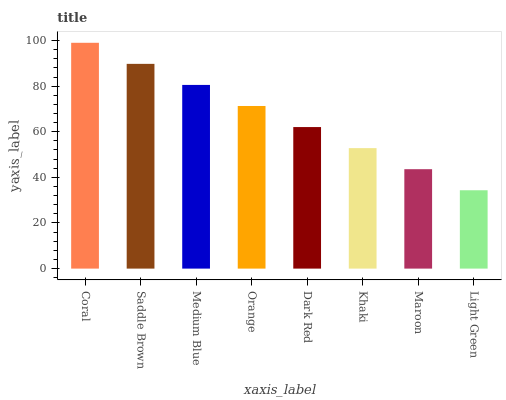Is Light Green the minimum?
Answer yes or no. Yes. Is Coral the maximum?
Answer yes or no. Yes. Is Saddle Brown the minimum?
Answer yes or no. No. Is Saddle Brown the maximum?
Answer yes or no. No. Is Coral greater than Saddle Brown?
Answer yes or no. Yes. Is Saddle Brown less than Coral?
Answer yes or no. Yes. Is Saddle Brown greater than Coral?
Answer yes or no. No. Is Coral less than Saddle Brown?
Answer yes or no. No. Is Orange the high median?
Answer yes or no. Yes. Is Dark Red the low median?
Answer yes or no. Yes. Is Maroon the high median?
Answer yes or no. No. Is Maroon the low median?
Answer yes or no. No. 